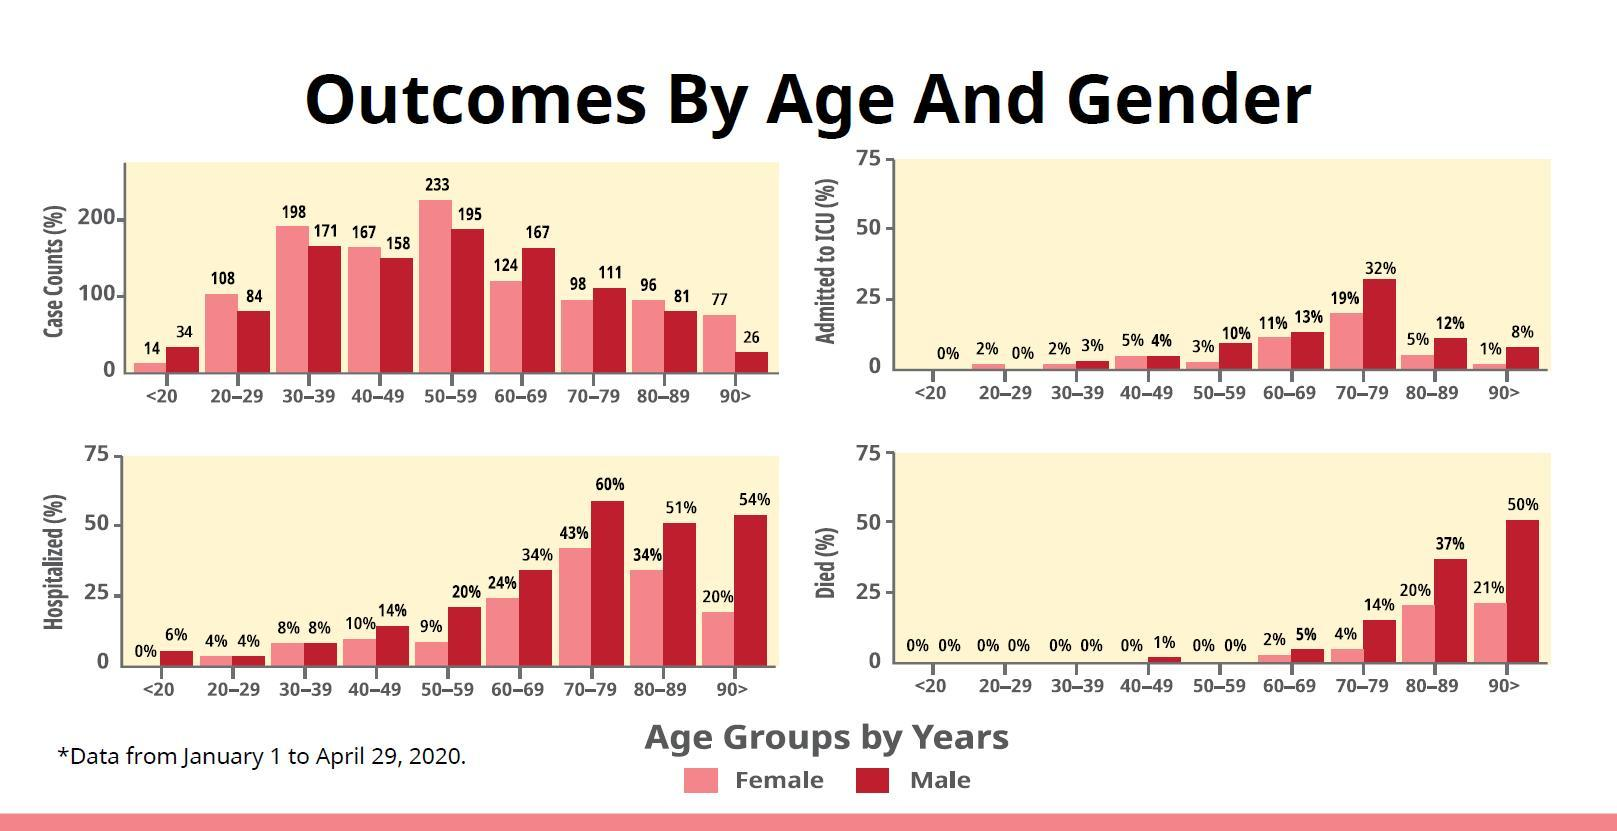What is the total percentage of males and females died in the age group 80-89?
Answer the question with a short phrase. 57% What is the difference between males and females admitted to ICU in the age group 80-89? 7% What is the difference between hospitalized males and females in the age group of 70-79? 17% What is the difference between hospitalized males and females in the age group of 50-59? 11% What is the difference between males and females admitted to ICU in the age group 30-39? 1% What is the difference between the case counts of males and females in the age group of 60-69? 43 What is the difference between the case counts of males and females in the age group of 70-79? 13 What is the total percentage of males and females died in the age group 70-79? 18% 